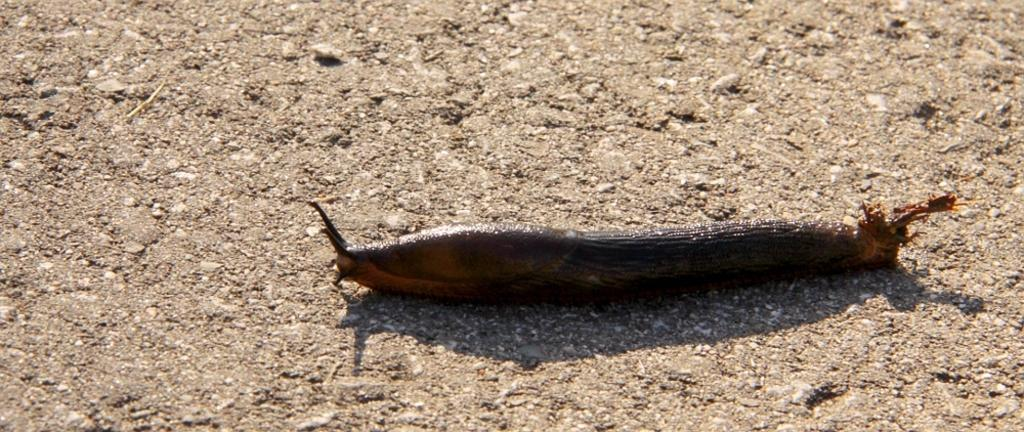What type of creature is in the image? There is a slug in the image. Where is the slug located? The slug is on the ground. What type of plant is the slug using as a ramp in the image? There is no plant or ramp present in the image; the slug is simply on the ground. 